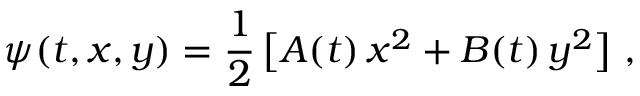<formula> <loc_0><loc_0><loc_500><loc_500>\psi ( t , x , y ) = \frac { 1 } { 2 } \, \left [ A ( t ) \, x ^ { 2 } + B ( t ) \, y ^ { 2 } \right ] \ ,</formula> 